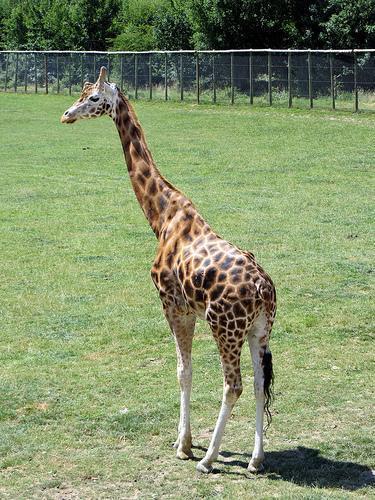How many giraffe are there?
Give a very brief answer. 1. 